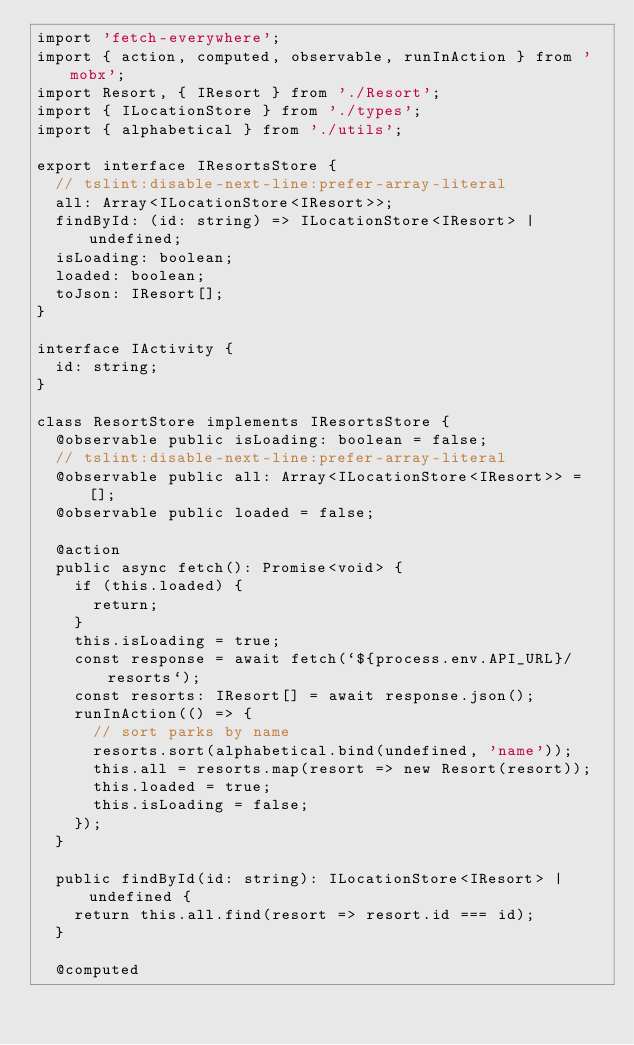Convert code to text. <code><loc_0><loc_0><loc_500><loc_500><_TypeScript_>import 'fetch-everywhere';
import { action, computed, observable, runInAction } from 'mobx';
import Resort, { IResort } from './Resort';
import { ILocationStore } from './types';
import { alphabetical } from './utils';

export interface IResortsStore {
  // tslint:disable-next-line:prefer-array-literal
  all: Array<ILocationStore<IResort>>;
  findById: (id: string) => ILocationStore<IResort> | undefined;
  isLoading: boolean;
  loaded: boolean;
  toJson: IResort[];
}

interface IActivity {
  id: string;
}

class ResortStore implements IResortsStore {
  @observable public isLoading: boolean = false;
  // tslint:disable-next-line:prefer-array-literal
  @observable public all: Array<ILocationStore<IResort>> = [];
  @observable public loaded = false;

  @action
  public async fetch(): Promise<void> {
    if (this.loaded) {
      return;
    }
    this.isLoading = true;
    const response = await fetch(`${process.env.API_URL}/resorts`);
    const resorts: IResort[] = await response.json();
    runInAction(() => {
      // sort parks by name
      resorts.sort(alphabetical.bind(undefined, 'name'));
      this.all = resorts.map(resort => new Resort(resort));
      this.loaded = true;
      this.isLoading = false;
    });
  }

  public findById(id: string): ILocationStore<IResort> | undefined {
    return this.all.find(resort => resort.id === id);
  }

  @computed</code> 